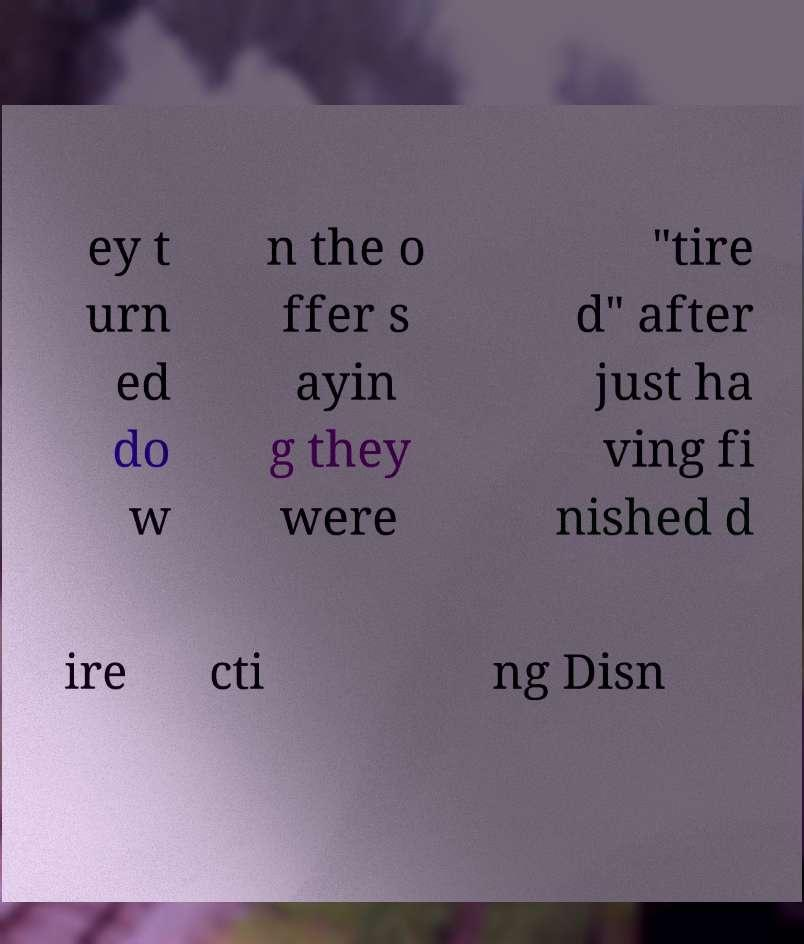Could you assist in decoding the text presented in this image and type it out clearly? ey t urn ed do w n the o ffer s ayin g they were "tire d" after just ha ving fi nished d ire cti ng Disn 